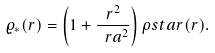Convert formula to latex. <formula><loc_0><loc_0><loc_500><loc_500>\varrho _ { * } ( r ) = \left ( 1 + \frac { r ^ { 2 } } { \ r a ^ { 2 } } \right ) \rho s t a r ( r ) .</formula> 